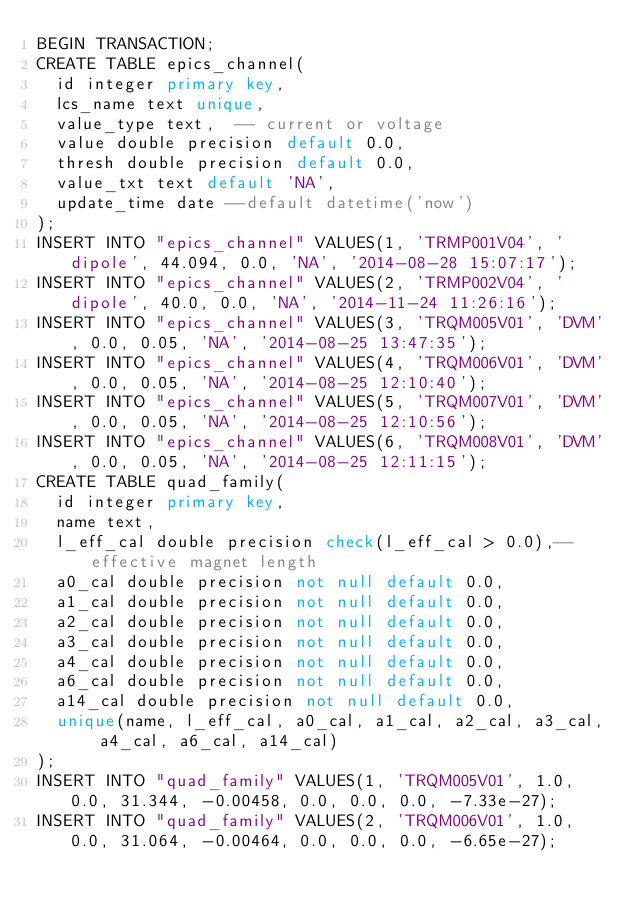<code> <loc_0><loc_0><loc_500><loc_500><_SQL_>BEGIN TRANSACTION;
CREATE TABLE epics_channel(
  id integer primary key,
  lcs_name text unique,
  value_type text,  -- current or voltage
  value double precision default 0.0,
  thresh double precision default 0.0,
  value_txt text default 'NA',
  update_time date --default datetime('now')
);
INSERT INTO "epics_channel" VALUES(1, 'TRMP001V04', 'dipole', 44.094, 0.0, 'NA', '2014-08-28 15:07:17');
INSERT INTO "epics_channel" VALUES(2, 'TRMP002V04', 'dipole', 40.0, 0.0, 'NA', '2014-11-24 11:26:16');
INSERT INTO "epics_channel" VALUES(3, 'TRQM005V01', 'DVM', 0.0, 0.05, 'NA', '2014-08-25 13:47:35');
INSERT INTO "epics_channel" VALUES(4, 'TRQM006V01', 'DVM', 0.0, 0.05, 'NA', '2014-08-25 12:10:40');
INSERT INTO "epics_channel" VALUES(5, 'TRQM007V01', 'DVM', 0.0, 0.05, 'NA', '2014-08-25 12:10:56');
INSERT INTO "epics_channel" VALUES(6, 'TRQM008V01', 'DVM', 0.0, 0.05, 'NA', '2014-08-25 12:11:15');
CREATE TABLE quad_family(
  id integer primary key,
  name text,
  l_eff_cal double precision check(l_eff_cal > 0.0),-- effective magnet length
  a0_cal double precision not null default 0.0,
  a1_cal double precision not null default 0.0,
  a2_cal double precision not null default 0.0,
  a3_cal double precision not null default 0.0,
  a4_cal double precision not null default 0.0,
  a6_cal double precision not null default 0.0,
  a14_cal double precision not null default 0.0,
  unique(name, l_eff_cal, a0_cal, a1_cal, a2_cal, a3_cal, a4_cal, a6_cal, a14_cal)
);
INSERT INTO "quad_family" VALUES(1, 'TRQM005V01', 1.0, 0.0, 31.344, -0.00458, 0.0, 0.0, 0.0, -7.33e-27);
INSERT INTO "quad_family" VALUES(2, 'TRQM006V01', 1.0, 0.0, 31.064, -0.00464, 0.0, 0.0, 0.0, -6.65e-27);</code> 